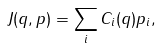Convert formula to latex. <formula><loc_0><loc_0><loc_500><loc_500>J ( { q , p } ) = \sum _ { i } C _ { i } ( { q } ) p _ { i } ,</formula> 